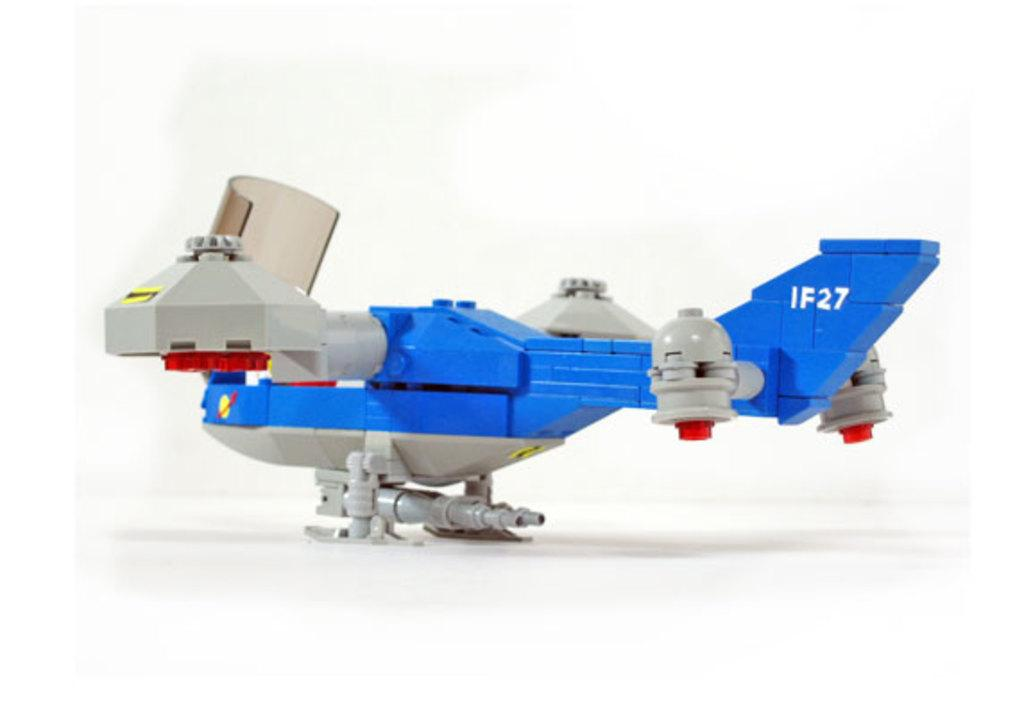What is the main subject of the image? The main subject of the image is a toy aeroplane. Where is the toy aeroplane located in the image? The toy aeroplane is in the center of the image. What type of loaf is being sliced on the desk in the image? There is no loaf or desk present in the image; it only features a toy aeroplane. 